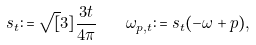Convert formula to latex. <formula><loc_0><loc_0><loc_500><loc_500>s _ { t } \colon = \sqrt { [ } 3 ] { \frac { 3 t } { 4 \pi } } \quad \omega _ { p , t } \colon = s _ { t } ( - \omega + p ) ,</formula> 